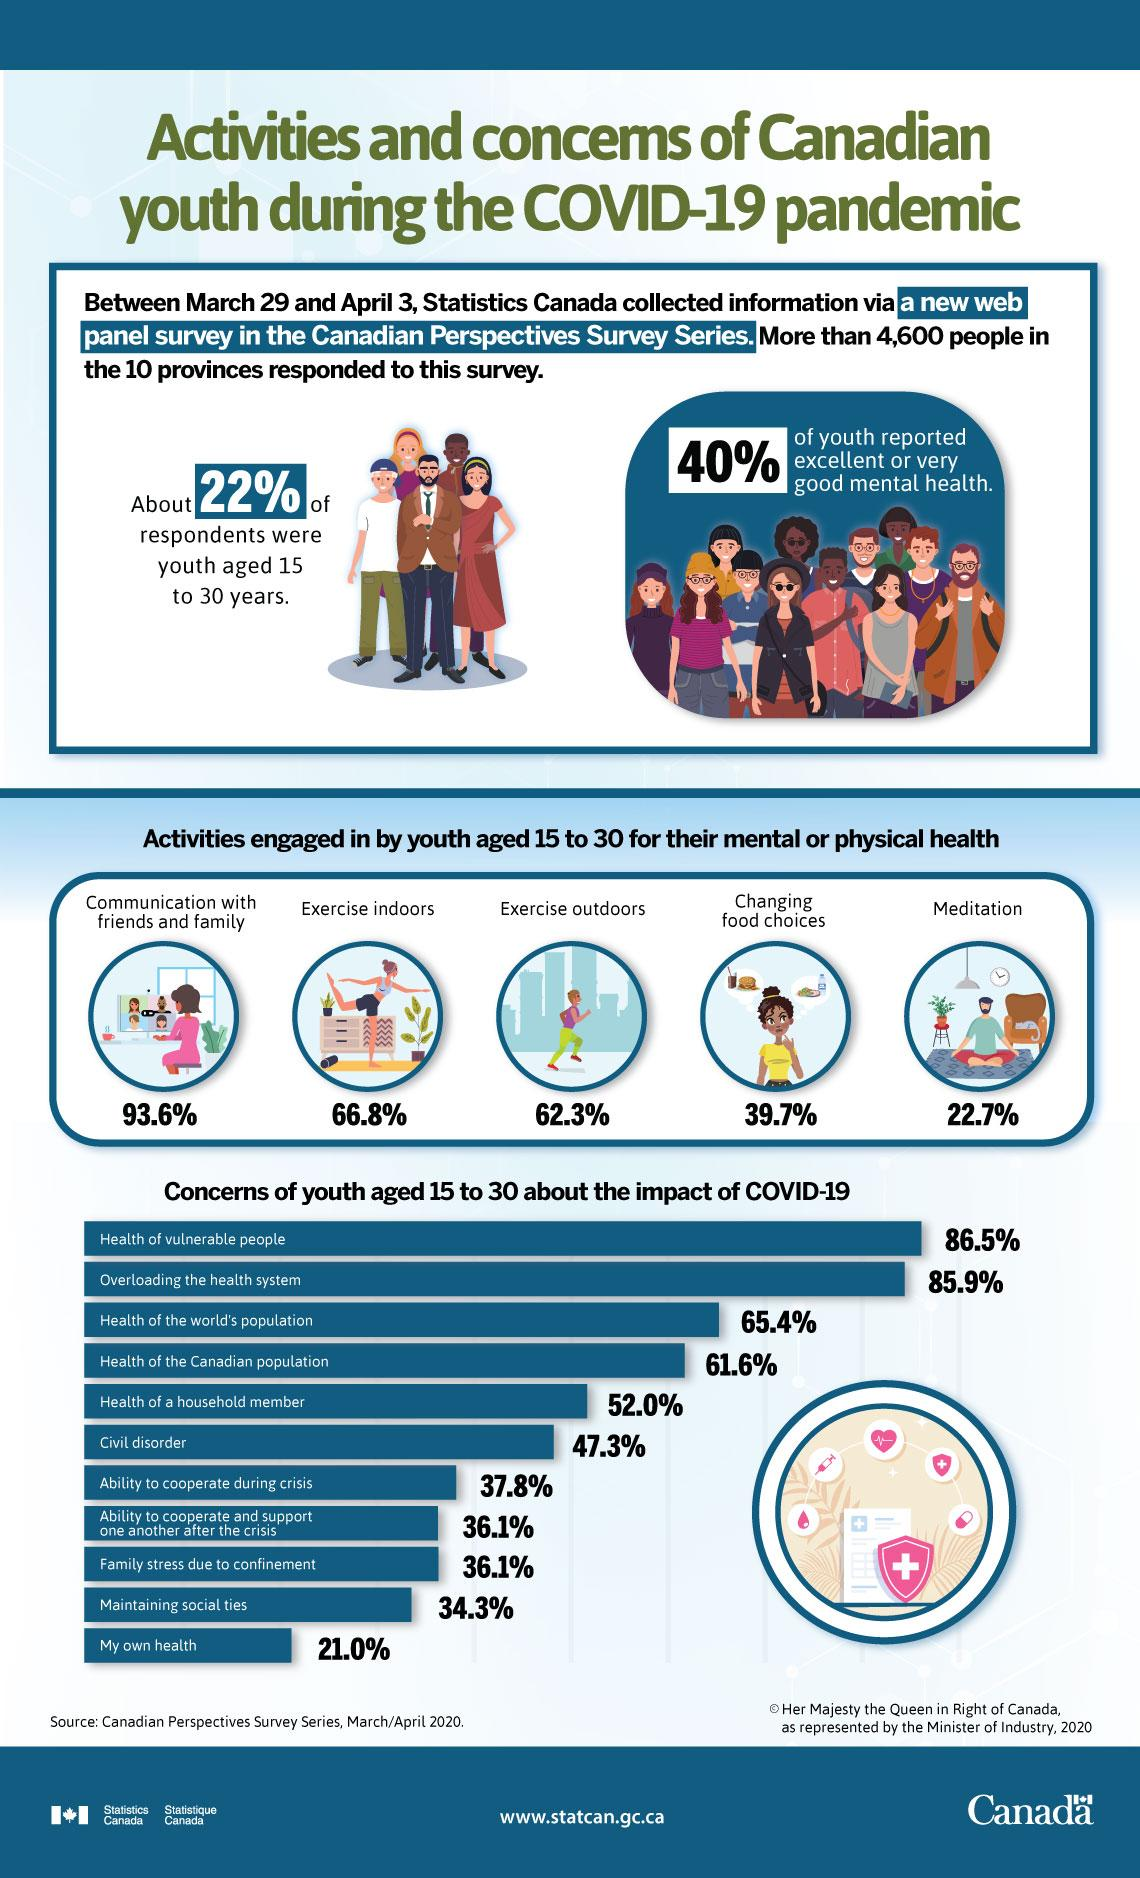Mention a couple of crucial points in this snapshot. According to a survey, 65.7% of Canadian youth aged 15 to 30 years showed no concern about maintaining social ties during the COVID-19 pandemic. According to a survey, 22.7% of Canadian youth aged 15 to 30 years engaged in meditation for their mental health. According to a survey, 62.3% of Canadian youth aged 15 to 30 years engaged in outdoor exercises for maintaining their physical health. According to a survey, 66.8% of Canadian youth aged 15 to 30 years engaged in indoor exercises for maintaining their physical health. According to a survey, 38.4% of Canadian youth aged 15 to 30 years were not worried about the health of the Canadian population during the COVID-19 pandemic. 